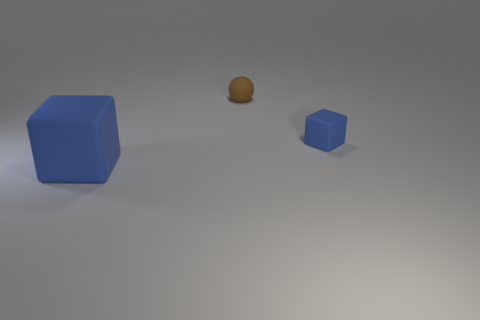Add 3 large cubes. How many objects exist? 6 Subtract all cubes. How many objects are left? 1 Add 3 tiny brown objects. How many tiny brown objects are left? 4 Add 1 small metal cylinders. How many small metal cylinders exist? 1 Subtract 0 red cubes. How many objects are left? 3 Subtract all large gray cubes. Subtract all tiny rubber cubes. How many objects are left? 2 